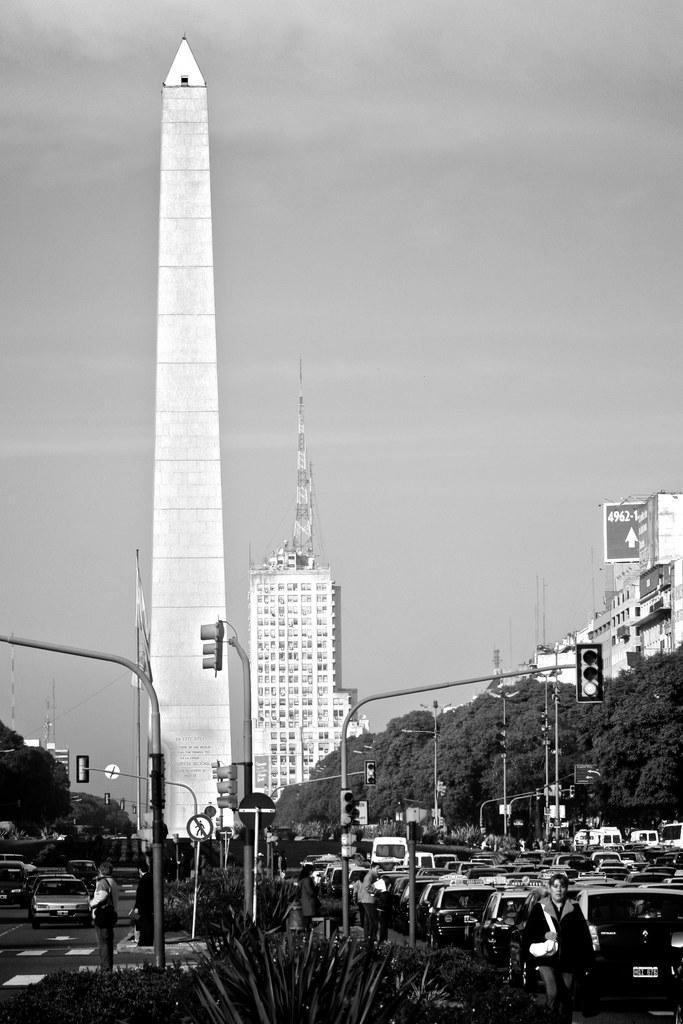Can you describe this image briefly? This is a black and white pic. At the bottom we can see few persons, plants, traffic signal poles and vehicles on the roads. In the background there are trees, buildings, hoarding, poles, towers and clouds in the sky. 